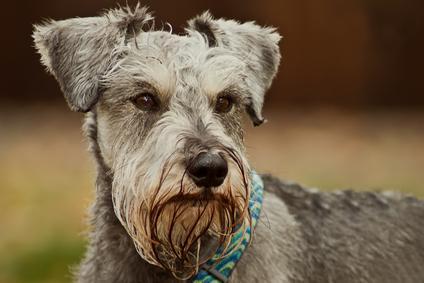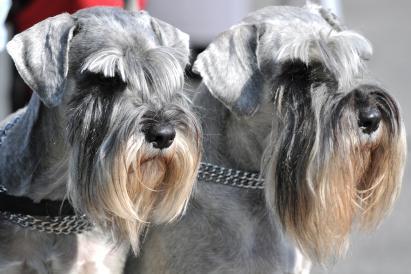The first image is the image on the left, the second image is the image on the right. Assess this claim about the two images: "There is grass visible on one of the images.". Correct or not? Answer yes or no. No. 